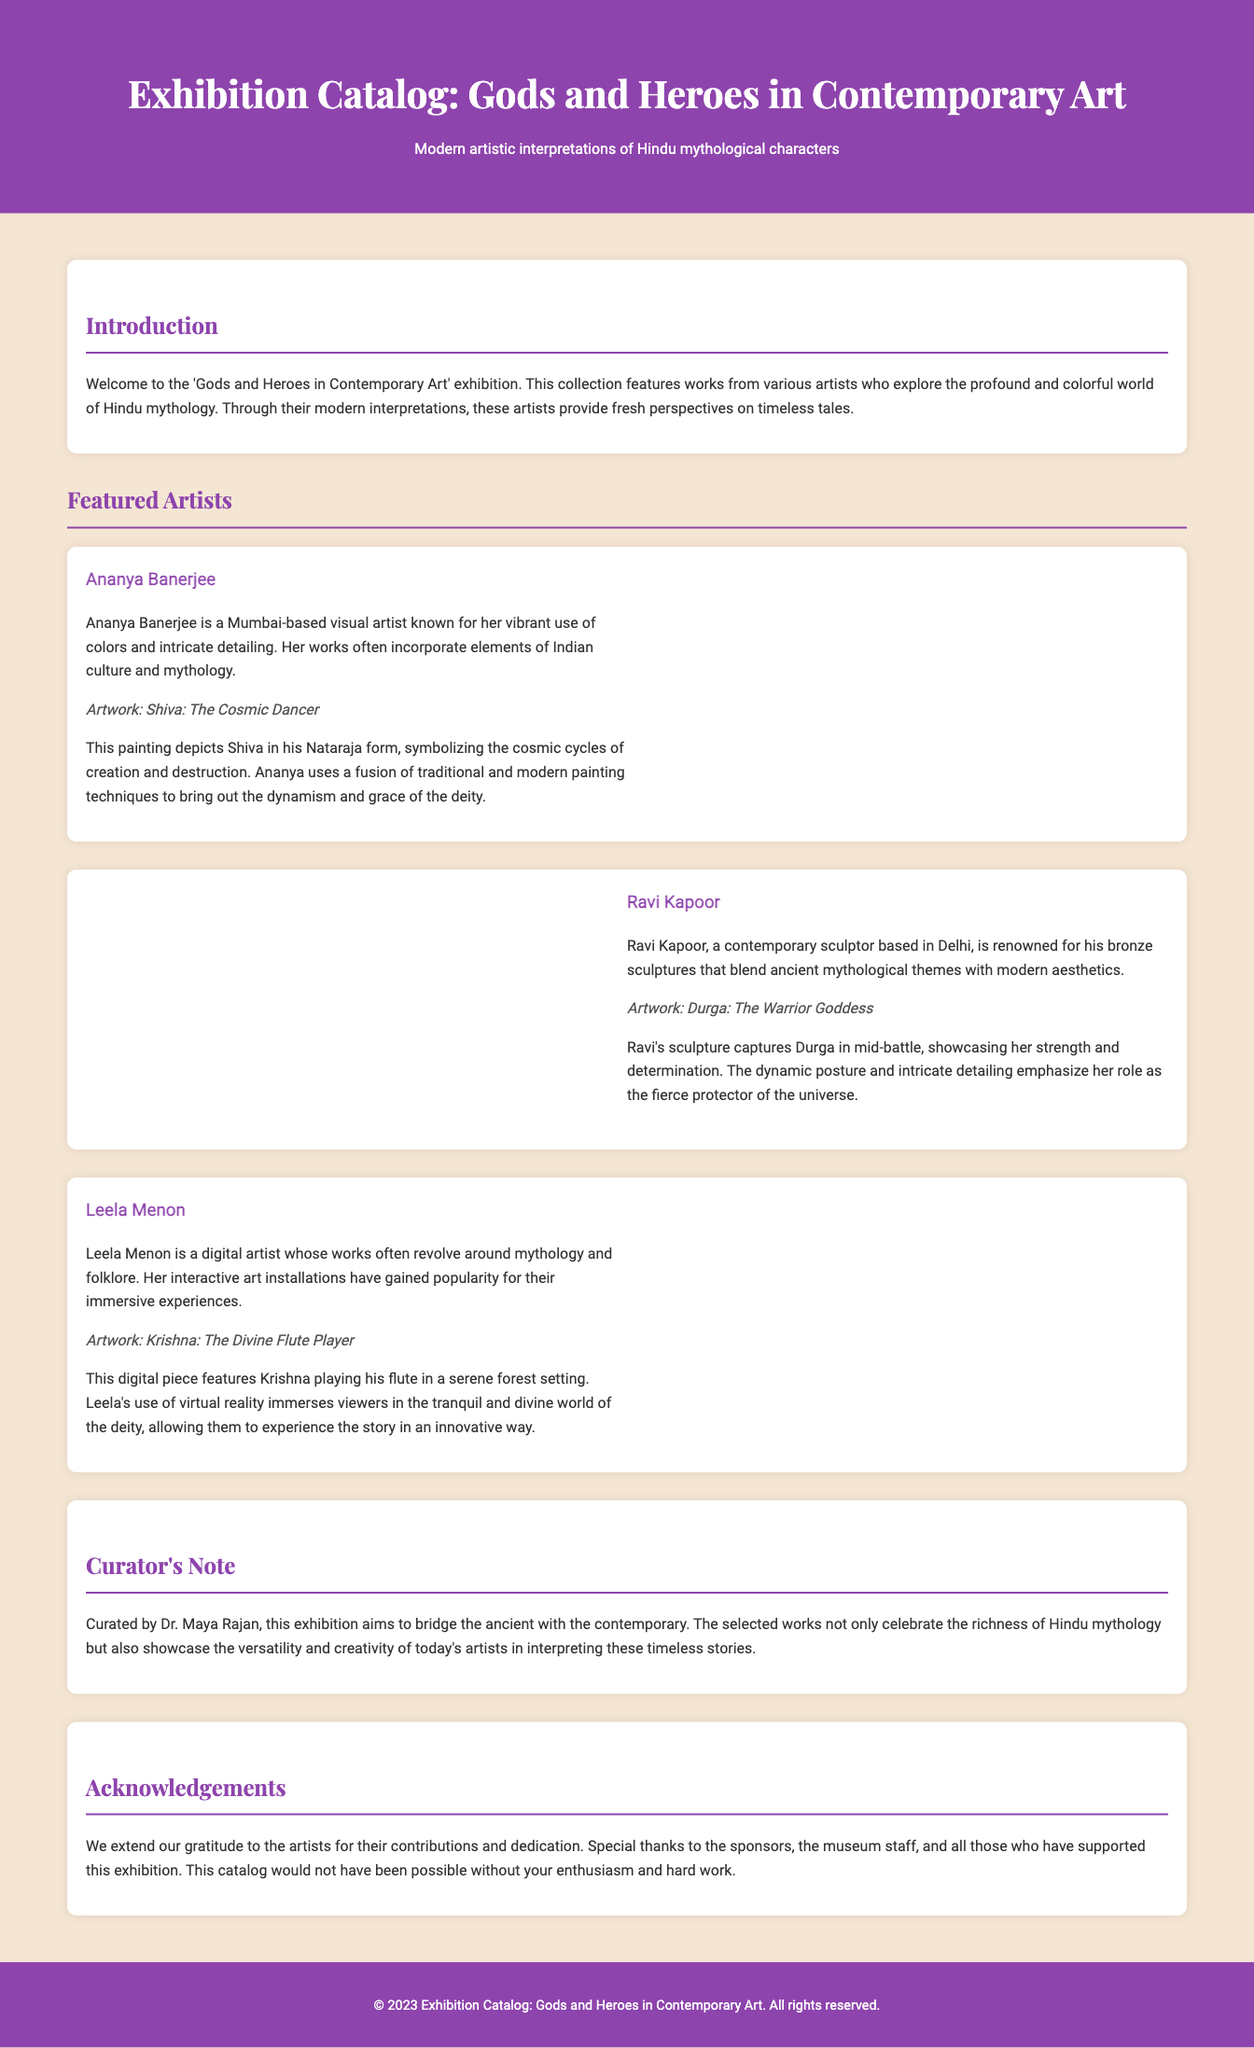what is the title of the exhibition? The title of the exhibition is prominently featured at the top of the document.
Answer: Gods and Heroes in Contemporary Art who is the curator of the exhibition? The curator is mentioned in the curator's note section of the document.
Answer: Dr. Maya Rajan how many featured artists are listed in the catalog? The document lists three artists in the featured section.
Answer: Three what artwork is created by Ananya Banerjee? Ananya Banerjee's artwork is titled in her section of the document.
Answer: Shiva: The Cosmic Dancer what medium does Ravi Kapoor primarily work with? The document describes Ravi Kapoor as a sculptor known for a specific medium.
Answer: Bronze which digital artist created an immersive experience? The document specifies that Leela Menon is a digital artist known for her interactive art installations.
Answer: Leela Menon what is the main theme of the exhibition? The introduction section explains the overarching theme of the collection.
Answer: Hindu mythology what is the purpose of the acknowledgements section? The acknowledgments are meant to express gratitude towards contributors and supporters of the exhibition.
Answer: Gratitude 